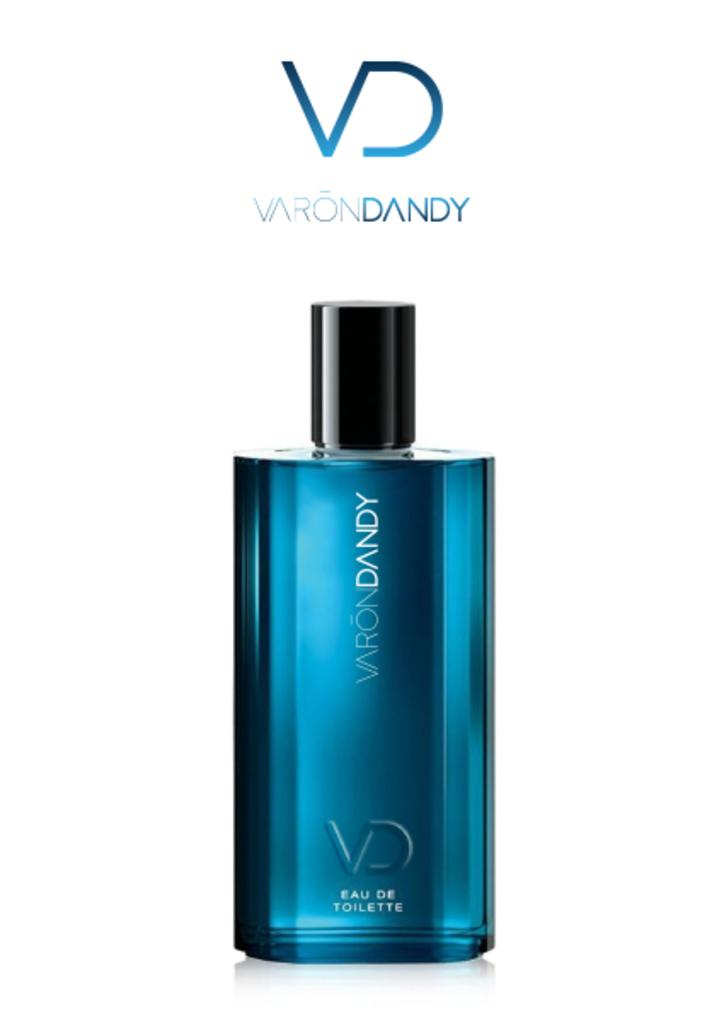Provide a one-sentence caption for the provided image. A blue bottle of Varon Dandy perfume is displayed in a white background. 